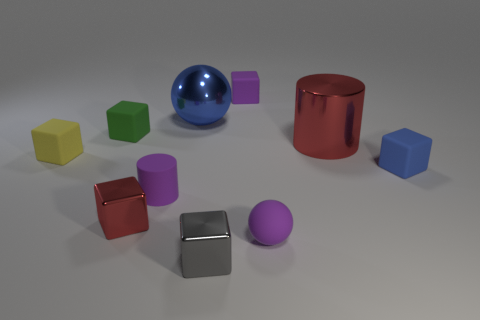There is a tiny matte object that is the same color as the big sphere; what is its shape?
Give a very brief answer. Cube. The blue object on the left side of the tiny purple object that is behind the tiny yellow matte thing is what shape?
Your answer should be compact. Sphere. There is a red metal object that is the same size as the blue ball; what shape is it?
Offer a terse response. Cylinder. Is there a tiny rubber sphere that has the same color as the tiny rubber cylinder?
Your answer should be very brief. Yes. Are there the same number of red things that are left of the small red object and tiny purple blocks that are in front of the yellow matte block?
Provide a succinct answer. Yes. Is the shape of the green rubber object the same as the red thing that is behind the small blue matte cube?
Provide a succinct answer. No. How many other things are there of the same material as the tiny gray object?
Keep it short and to the point. 3. Are there any red shiny things behind the tiny yellow matte object?
Keep it short and to the point. Yes. There is a blue rubber thing; is it the same size as the red thing that is left of the purple sphere?
Keep it short and to the point. Yes. What is the color of the cylinder that is in front of the small object that is right of the red cylinder?
Your answer should be very brief. Purple. 